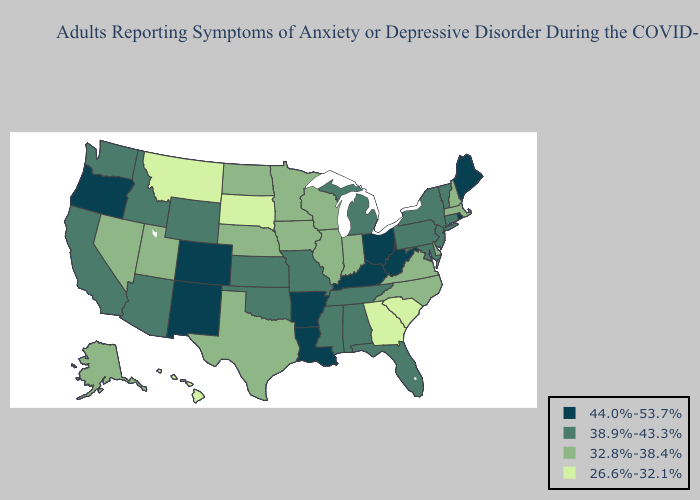What is the lowest value in the USA?
Concise answer only. 26.6%-32.1%. Does West Virginia have the lowest value in the South?
Concise answer only. No. What is the lowest value in states that border Oregon?
Quick response, please. 32.8%-38.4%. Does Indiana have the same value as Nebraska?
Be succinct. Yes. What is the value of Vermont?
Give a very brief answer. 38.9%-43.3%. Does Montana have the lowest value in the West?
Concise answer only. Yes. Name the states that have a value in the range 26.6%-32.1%?
Quick response, please. Georgia, Hawaii, Montana, South Carolina, South Dakota. What is the value of Alaska?
Concise answer only. 32.8%-38.4%. What is the value of Ohio?
Short answer required. 44.0%-53.7%. Is the legend a continuous bar?
Short answer required. No. How many symbols are there in the legend?
Give a very brief answer. 4. What is the value of Vermont?
Answer briefly. 38.9%-43.3%. Name the states that have a value in the range 38.9%-43.3%?
Give a very brief answer. Alabama, Arizona, California, Connecticut, Florida, Idaho, Kansas, Maryland, Michigan, Mississippi, Missouri, New Jersey, New York, Oklahoma, Pennsylvania, Tennessee, Vermont, Washington, Wyoming. What is the value of Nebraska?
Concise answer only. 32.8%-38.4%. 